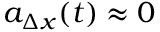<formula> <loc_0><loc_0><loc_500><loc_500>a _ { \Delta x } ( t ) \approx 0</formula> 